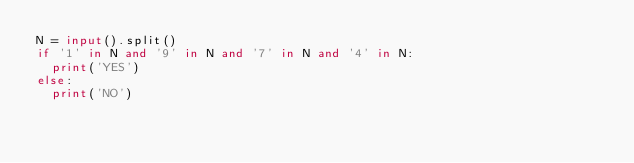<code> <loc_0><loc_0><loc_500><loc_500><_Python_>N = input().split()
if '1' in N and '9' in N and '7' in N and '4' in N:
  print('YES')
else:
  print('NO')</code> 